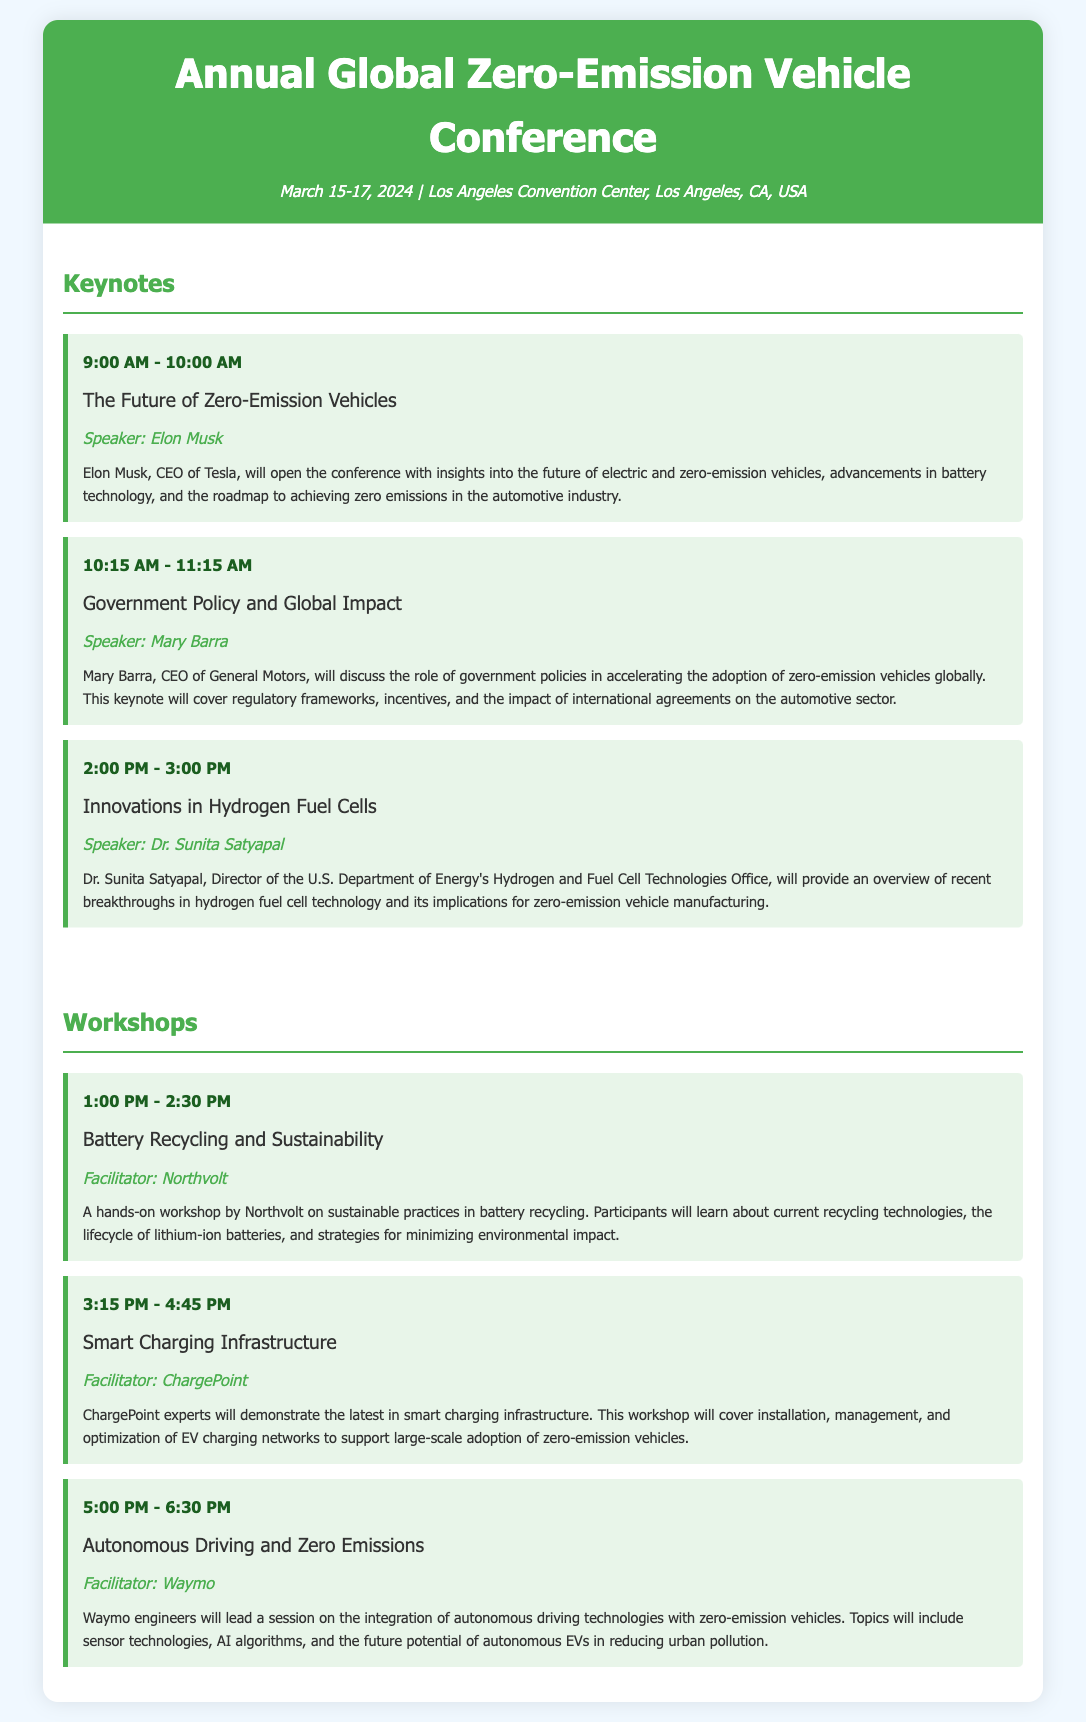What are the dates of the conference? The dates of the conference are clearly stated in the header of the document, which is March 15-17, 2024.
Answer: March 15-17, 2024 Who will speak about battery technology? The speaker discussing battery technology is mentioned in the title of the first keynote, which is "The Future of Zero-Emission Vehicles" by Elon Musk.
Answer: Elon Musk What workshop is facilitated by Northvolt? The document specifies that Northvolt facilitates the workshop titled "Battery Recycling and Sustainability."
Answer: Battery Recycling and Sustainability What is the time slot for the "Smart Charging Infrastructure" workshop? The document lists the time for the workshop under the workshops section, stating it occurs from 3:15 PM to 4:45 PM.
Answer: 3:15 PM - 4:45 PM How many keynotes are scheduled on the first day? By examining the keynotes section, there are three keynotes listed for the first day.
Answer: Three What topic is addressed by Dr. Sunita Satyapal? The document identifies the topic of the keynote by Dr. Sunita Satyapal as "Innovations in Hydrogen Fuel Cells."
Answer: Innovations in Hydrogen Fuel Cells Which organization is leading the workshop on autonomous driving? The document states that Waymo is the organization facilitating the workshop on autonomous driving.
Answer: Waymo What is the main theme of the conference? The conference focuses on zero-emission vehicles, as emphasized throughout the document.
Answer: Zero-emission vehicles 